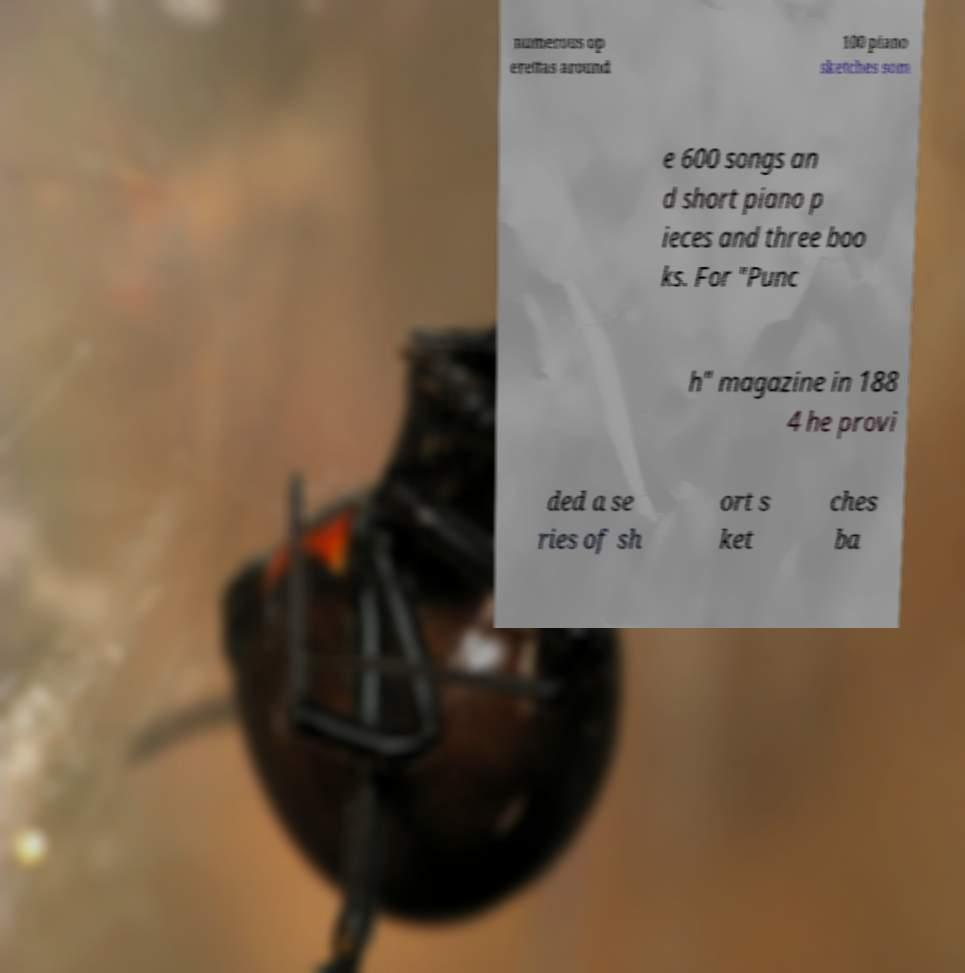For documentation purposes, I need the text within this image transcribed. Could you provide that? numerous op erettas around 100 piano sketches som e 600 songs an d short piano p ieces and three boo ks. For "Punc h" magazine in 188 4 he provi ded a se ries of sh ort s ket ches ba 